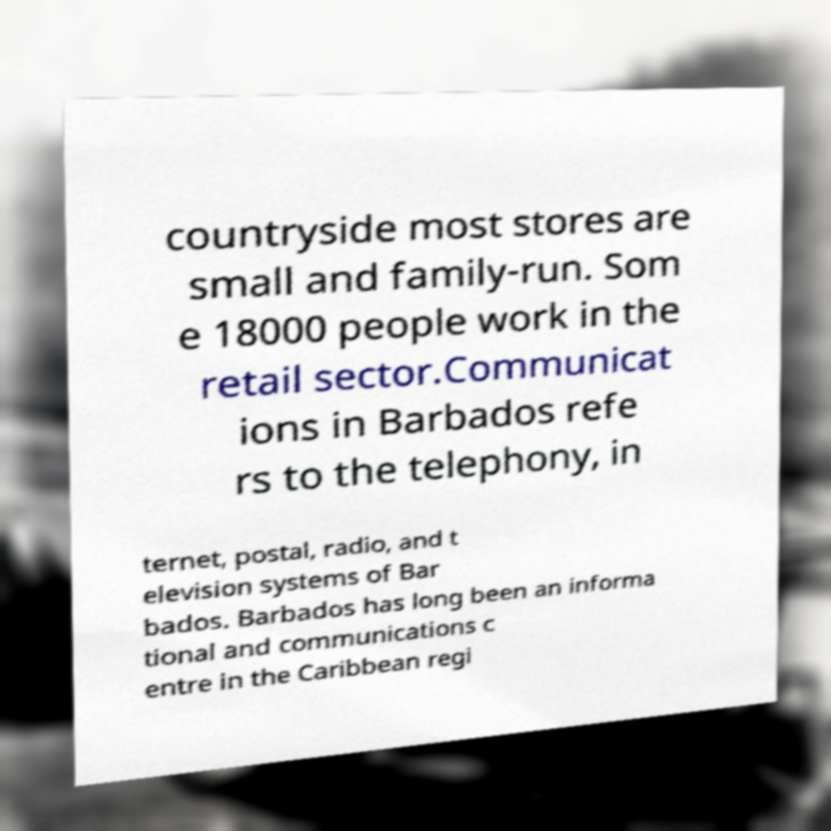Could you extract and type out the text from this image? countryside most stores are small and family-run. Som e 18000 people work in the retail sector.Communicat ions in Barbados refe rs to the telephony, in ternet, postal, radio, and t elevision systems of Bar bados. Barbados has long been an informa tional and communications c entre in the Caribbean regi 